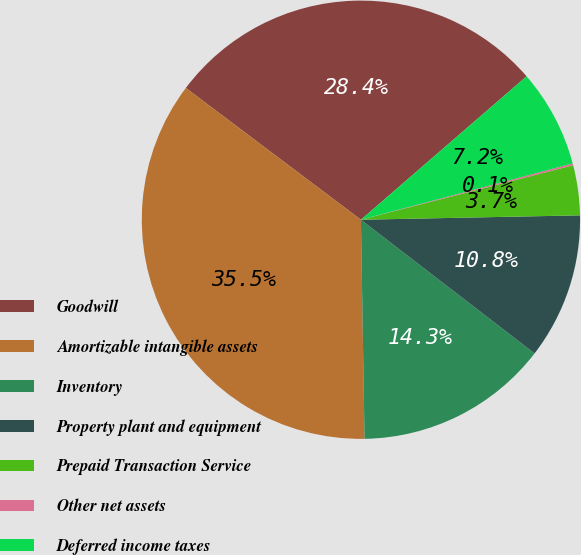<chart> <loc_0><loc_0><loc_500><loc_500><pie_chart><fcel>Goodwill<fcel>Amortizable intangible assets<fcel>Inventory<fcel>Property plant and equipment<fcel>Prepaid Transaction Service<fcel>Other net assets<fcel>Deferred income taxes<nl><fcel>28.38%<fcel>35.54%<fcel>14.3%<fcel>10.76%<fcel>3.68%<fcel>0.14%<fcel>7.22%<nl></chart> 